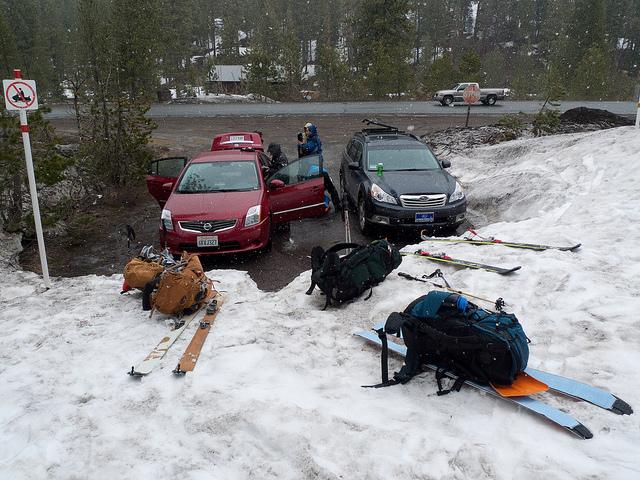What sort of outing are they embarking on? skiing 